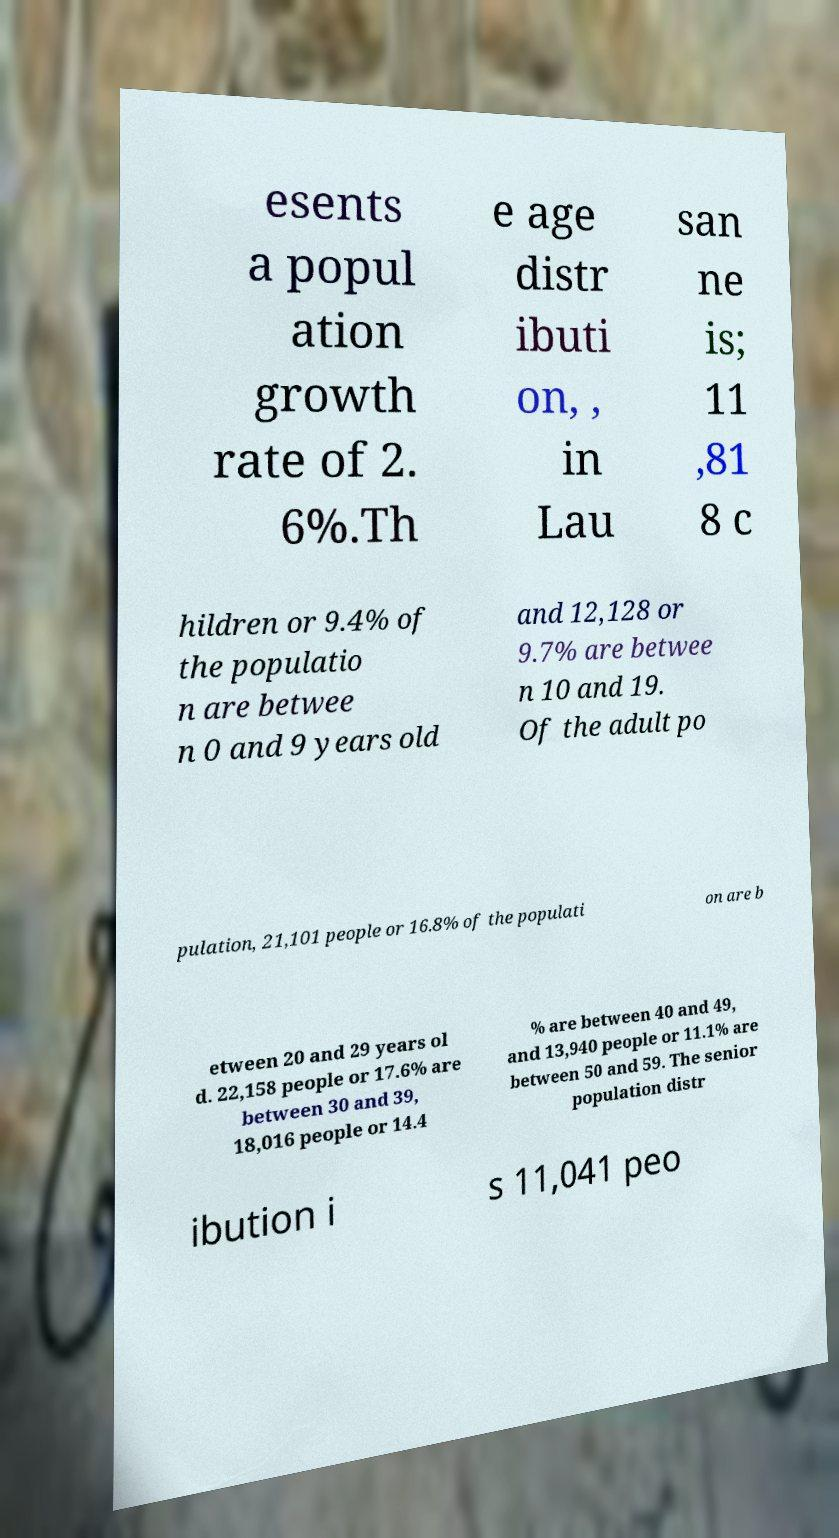Please read and relay the text visible in this image. What does it say? esents a popul ation growth rate of 2. 6%.Th e age distr ibuti on, , in Lau san ne is; 11 ,81 8 c hildren or 9.4% of the populatio n are betwee n 0 and 9 years old and 12,128 or 9.7% are betwee n 10 and 19. Of the adult po pulation, 21,101 people or 16.8% of the populati on are b etween 20 and 29 years ol d. 22,158 people or 17.6% are between 30 and 39, 18,016 people or 14.4 % are between 40 and 49, and 13,940 people or 11.1% are between 50 and 59. The senior population distr ibution i s 11,041 peo 